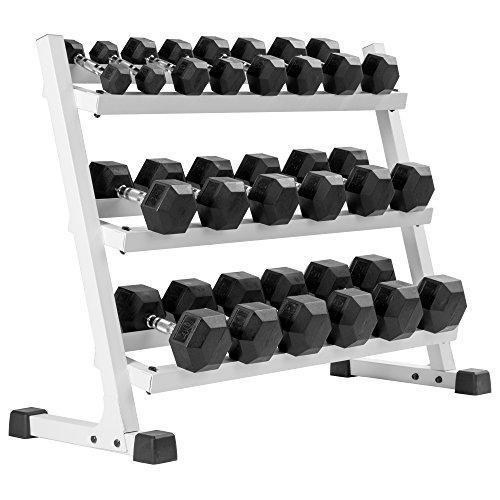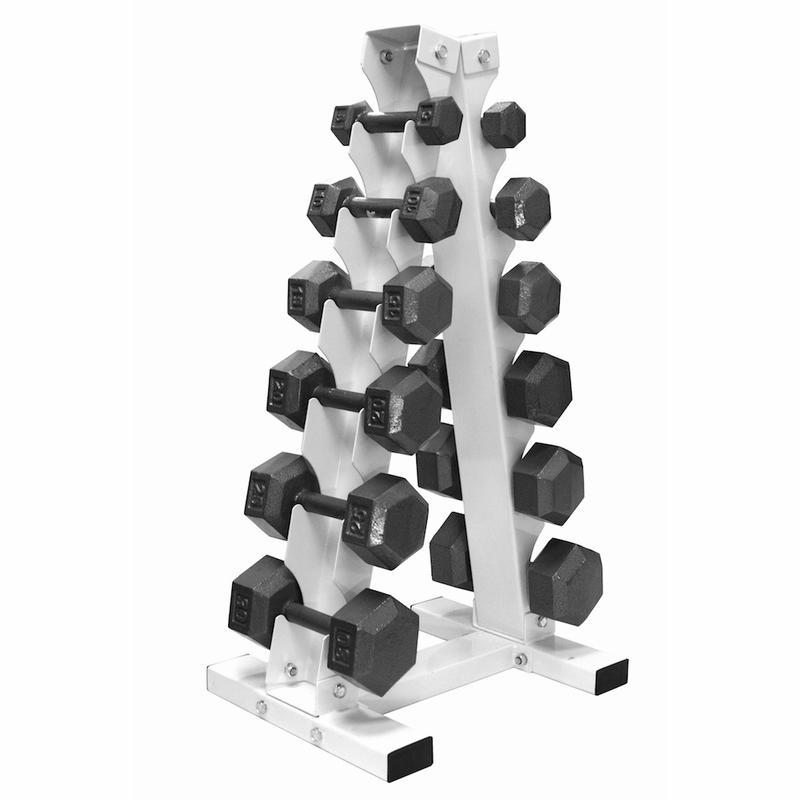The first image is the image on the left, the second image is the image on the right. Assess this claim about the two images: "Right image shows a weight rack with exactly two horizontal rows of dumbbells.". Correct or not? Answer yes or no. No. The first image is the image on the left, the second image is the image on the right. Analyze the images presented: Is the assertion "A white rack with three layers is in the left image." valid? Answer yes or no. Yes. 